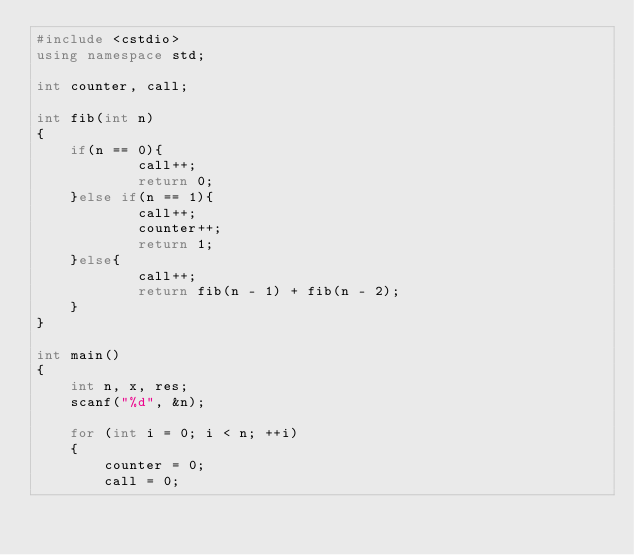Convert code to text. <code><loc_0><loc_0><loc_500><loc_500><_C++_>#include <cstdio>
using namespace std;

int counter, call;

int fib(int n)
{
    if(n == 0){
            call++;
            return 0;
    }else if(n == 1){
            call++;
            counter++;
            return 1;
    }else{
            call++;
            return fib(n - 1) + fib(n - 2);
    }
}

int main()
{
    int n, x, res;
    scanf("%d", &n);

    for (int i = 0; i < n; ++i)
    {
        counter = 0;
        call = 0;</code> 